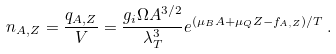Convert formula to latex. <formula><loc_0><loc_0><loc_500><loc_500>n _ { A , Z } = \frac { q _ { A , Z } } { V } = \frac { g _ { i } \Omega A ^ { 3 / 2 } } { \lambda _ { T } ^ { 3 } } e ^ { ( \mu _ { B } A + \mu _ { Q } Z - f _ { A , Z } ) / T } \, .</formula> 